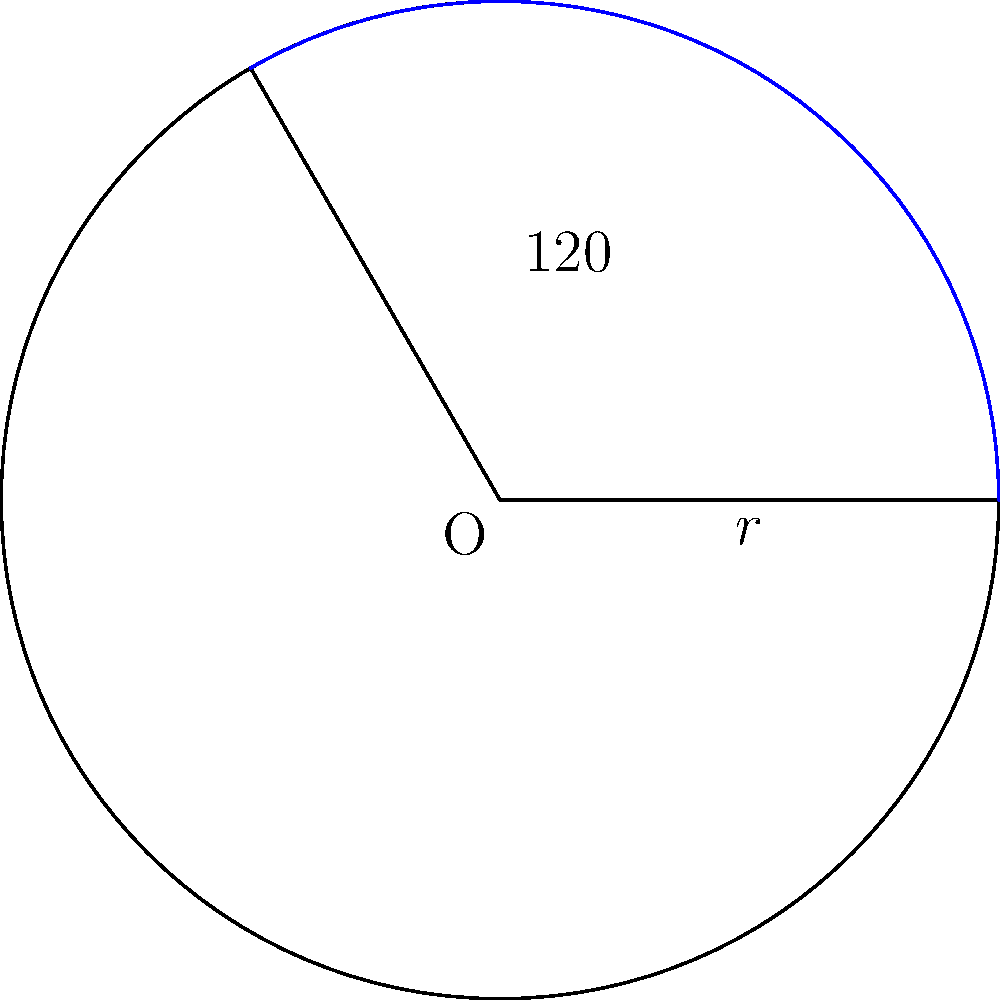In your latest chart-topping hit, you've incorporated a circular melody progression that spans 120° of a full rotation. If the radius of this musical circle is 8 meters, representing the song's dynamic range, what is the area of the sector that this melodic arc covers? Round your answer to two decimal places. To find the area of a circular sector, we can follow these steps:

1) The formula for the area of a circular sector is:

   $$A = \frac{1}{2}r^2\theta$$

   where $A$ is the area, $r$ is the radius, and $\theta$ is the central angle in radians.

2) We're given the angle in degrees (120°), so we need to convert it to radians:

   $$\theta = 120° \times \frac{\pi}{180°} = \frac{2\pi}{3} \approx 2.0944$$

3) Now we can substitute the values into our formula:

   $$A = \frac{1}{2} \times 8^2 \times \frac{2\pi}{3}$$

4) Simplify:

   $$A = 32 \times \frac{\pi}{3} \approx 33.5103$$

5) Rounding to two decimal places:

   $$A \approx 33.51 \text{ square meters}$$
Answer: 33.51 square meters 